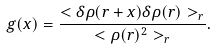Convert formula to latex. <formula><loc_0><loc_0><loc_500><loc_500>g ( x ) = \frac { < \delta \rho ( r + x ) \delta \rho ( r ) > _ { r } } { < \rho ( r ) ^ { 2 } > _ { r } } .</formula> 